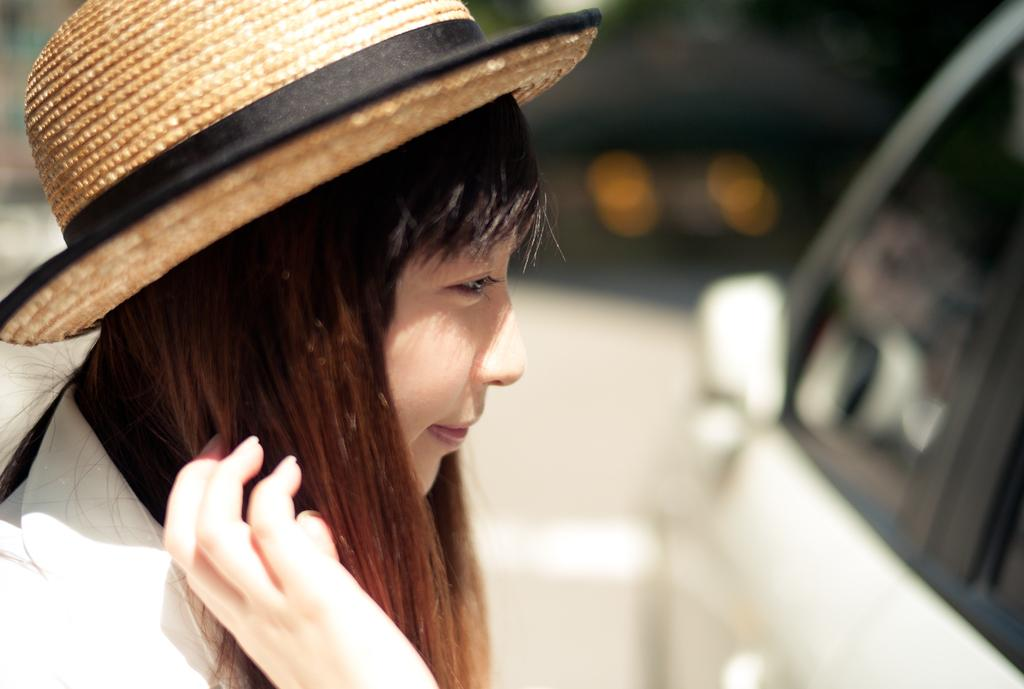What is the woman wearing on her head in the image? The woman is wearing a cap in the image. Where is the woman located in the image? The woman is on the left side of the image. What vehicle is visible in the image? There is a car in the image. Where is the car located in the image? The car is on the right side of the image. What news is the woman reading from the team in the image? There is no news or team present in the image; it only features a woman wearing a cap and a car. 